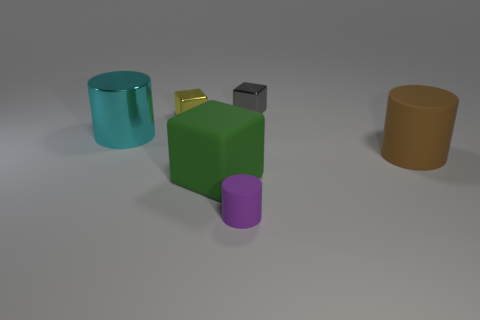Add 2 tiny brown metal cylinders. How many objects exist? 8 Subtract 0 red blocks. How many objects are left? 6 Subtract all cubes. Subtract all cyan metallic objects. How many objects are left? 2 Add 2 cyan cylinders. How many cyan cylinders are left? 3 Add 1 brown objects. How many brown objects exist? 2 